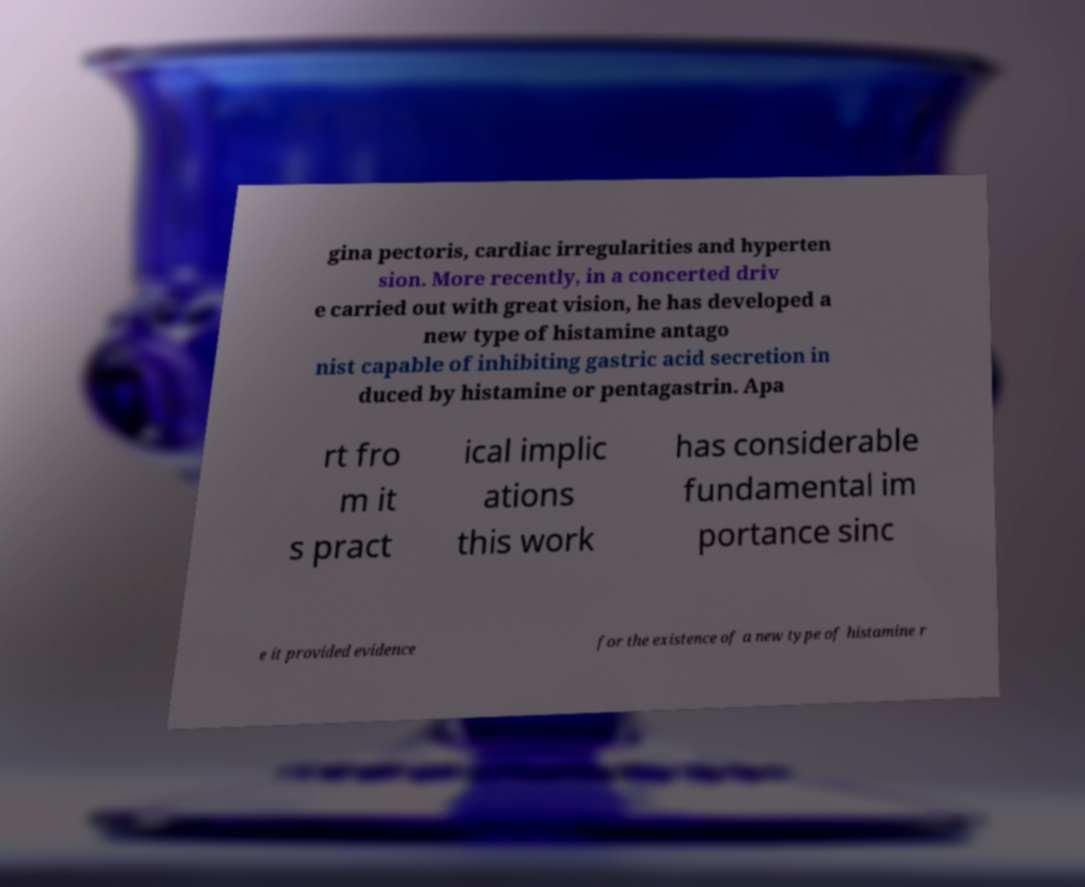Please read and relay the text visible in this image. What does it say? gina pectoris, cardiac irregularities and hyperten sion. More recently, in a concerted driv e carried out with great vision, he has developed a new type of histamine antago nist capable of inhibiting gastric acid secretion in duced by histamine or pentagastrin. Apa rt fro m it s pract ical implic ations this work has considerable fundamental im portance sinc e it provided evidence for the existence of a new type of histamine r 